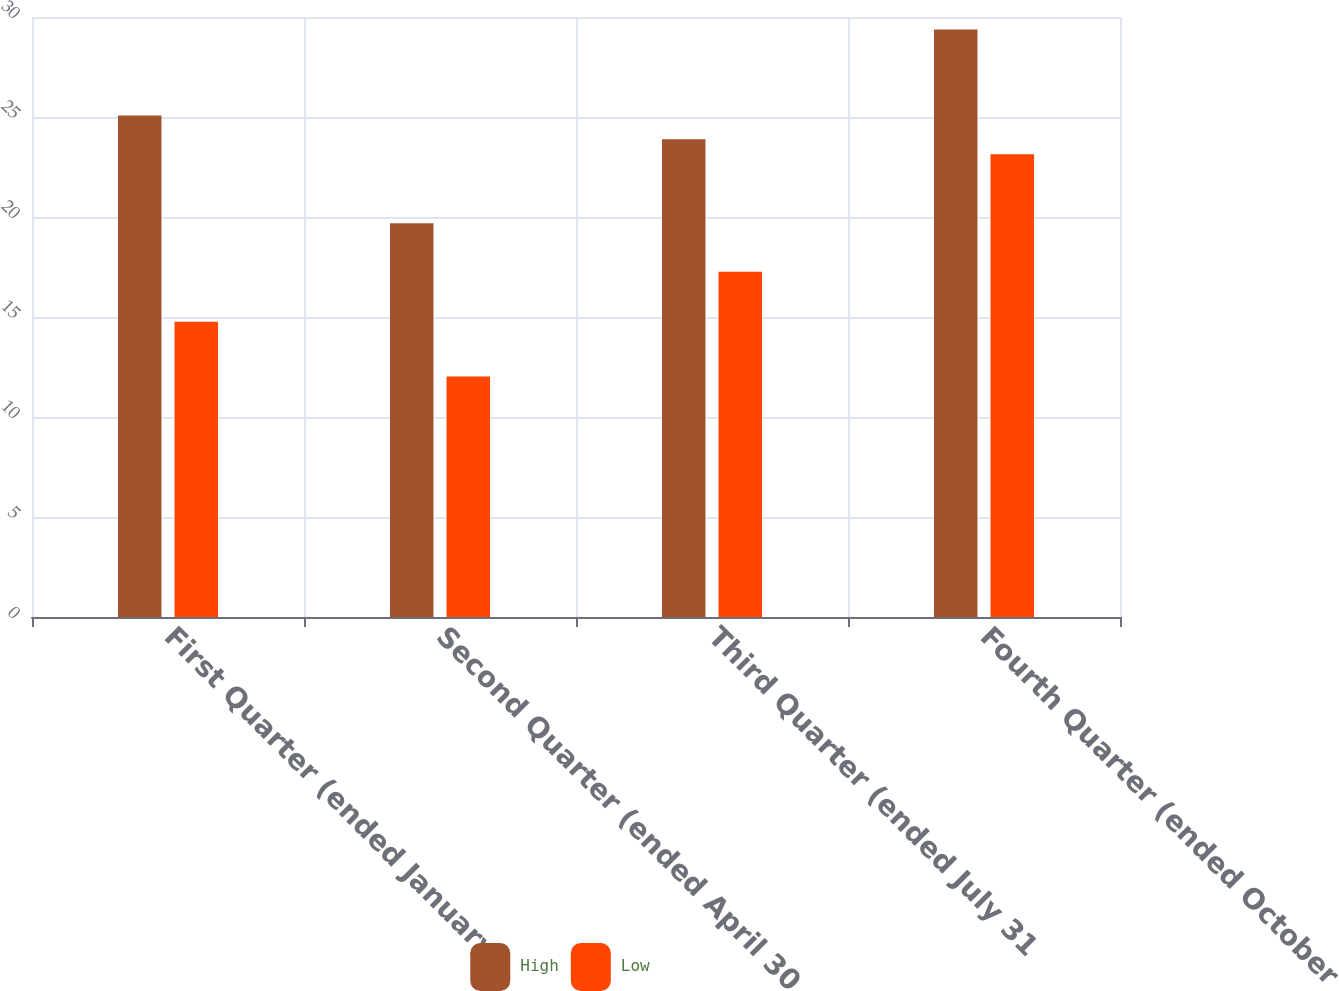Convert chart. <chart><loc_0><loc_0><loc_500><loc_500><stacked_bar_chart><ecel><fcel>First Quarter (ended January<fcel>Second Quarter (ended April 30<fcel>Third Quarter (ended July 31<fcel>Fourth Quarter (ended October<nl><fcel>High<fcel>25.07<fcel>19.69<fcel>23.89<fcel>29.38<nl><fcel>Low<fcel>14.76<fcel>12.02<fcel>17.26<fcel>23.14<nl></chart> 